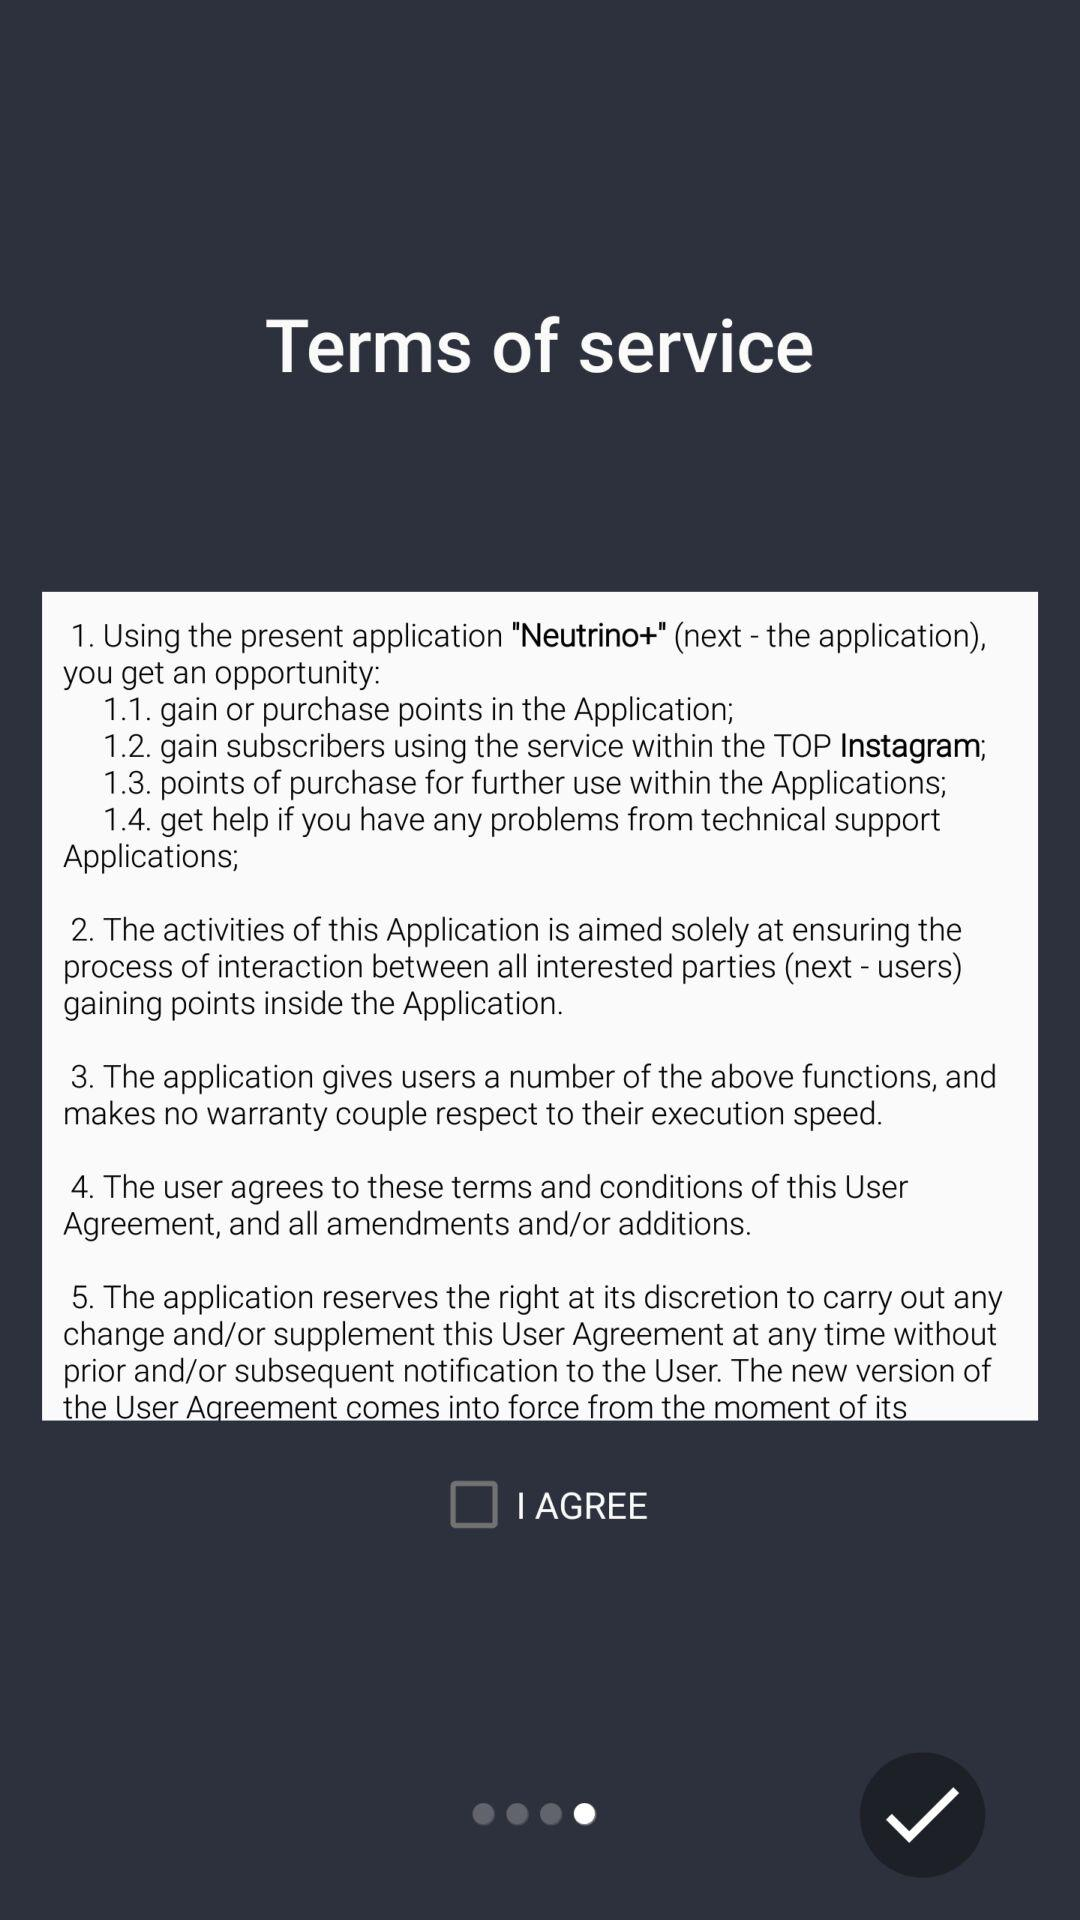How many terms of service are there?
Answer the question using a single word or phrase. 5 